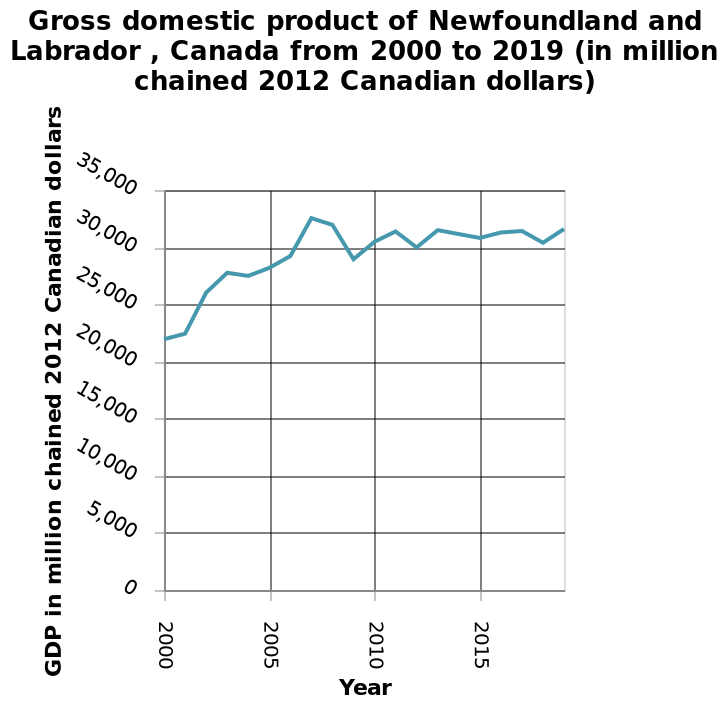<image>
Offer a thorough analysis of the image. The GDP rose sharply between 2000 and 2007, from 22,000m to 32,000m which was the peak. It then dropped slightly but has remained consistently above 30,000m since 2010. The GDP has been stable over the past decade. Has the GDP remained above 30,000m since 2010?  Yes, the GDP has remained consistently above 30,000m since 2010. 